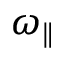<formula> <loc_0><loc_0><loc_500><loc_500>\omega _ { \| }</formula> 